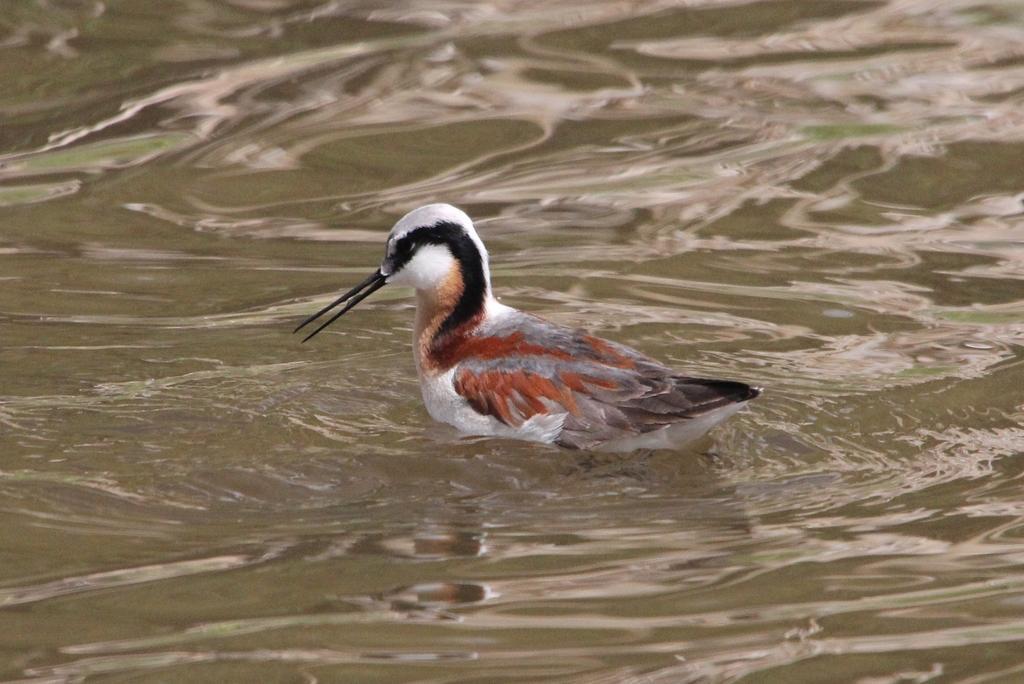In one or two sentences, can you explain what this image depicts? There is a duck in the water in the foreground area of the image. 